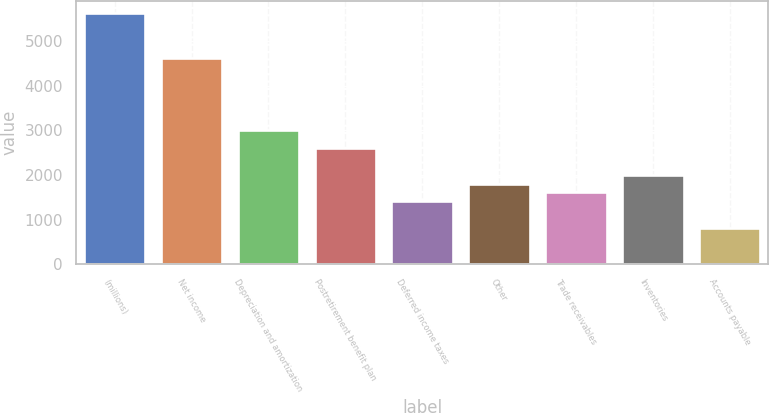<chart> <loc_0><loc_0><loc_500><loc_500><bar_chart><fcel>(millions)<fcel>Net income<fcel>Depreciation and amortization<fcel>Postretirement benefit plan<fcel>Deferred income taxes<fcel>Other<fcel>Trade receivables<fcel>Inventories<fcel>Accounts payable<nl><fcel>5623.6<fcel>4620.1<fcel>3014.5<fcel>2613.1<fcel>1408.9<fcel>1810.3<fcel>1609.6<fcel>2011<fcel>806.8<nl></chart> 